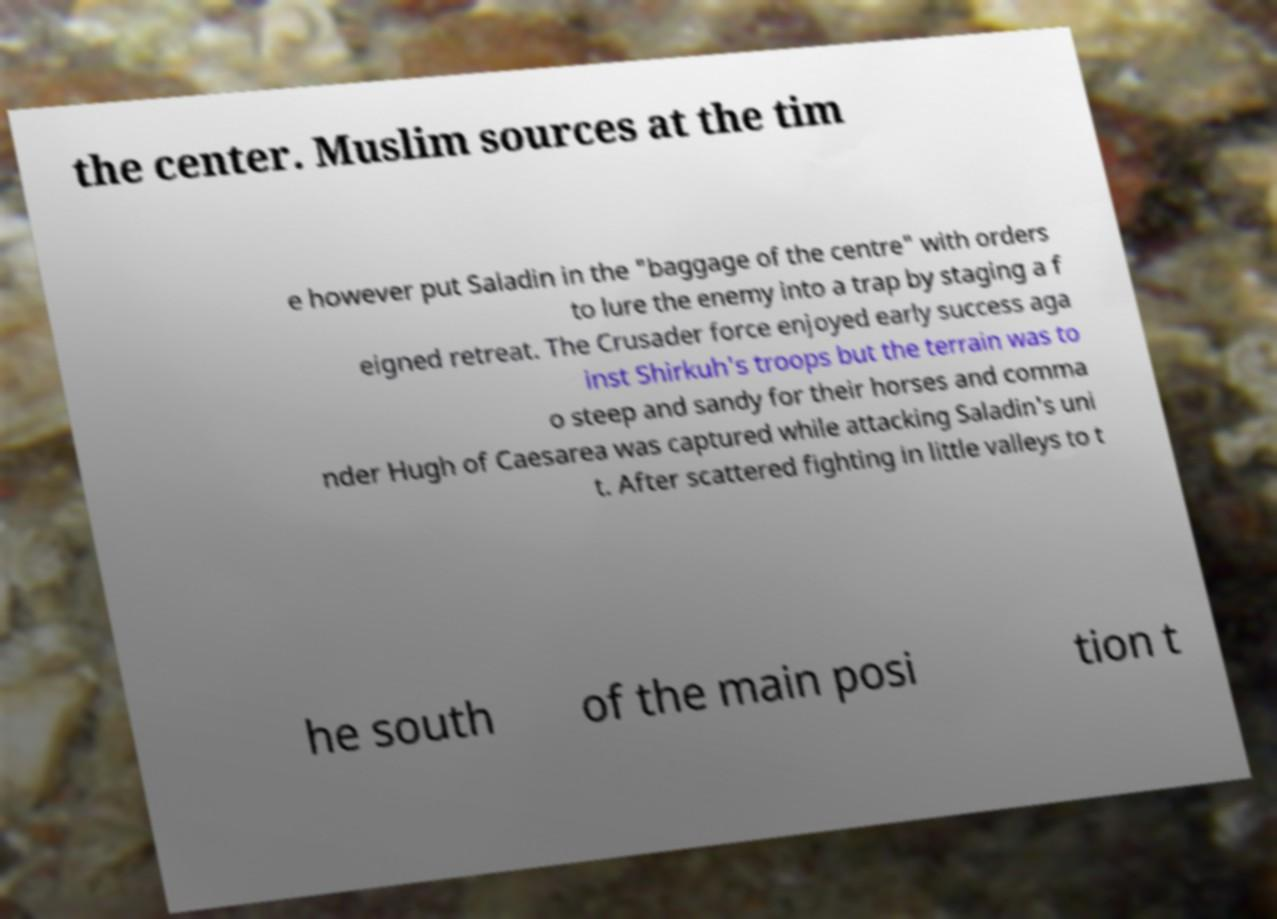There's text embedded in this image that I need extracted. Can you transcribe it verbatim? the center. Muslim sources at the tim e however put Saladin in the "baggage of the centre" with orders to lure the enemy into a trap by staging a f eigned retreat. The Crusader force enjoyed early success aga inst Shirkuh's troops but the terrain was to o steep and sandy for their horses and comma nder Hugh of Caesarea was captured while attacking Saladin's uni t. After scattered fighting in little valleys to t he south of the main posi tion t 